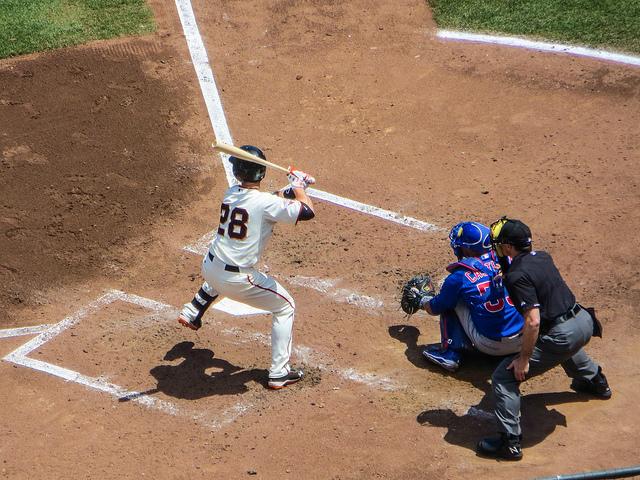Is the player going to hit the ball?
Short answer required. Yes. What is the green stuff in the top corners?
Give a very brief answer. Grass. What number player is at bat?
Be succinct. 28. 